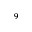<formula> <loc_0><loc_0><loc_500><loc_500>^ { 9 }</formula> 